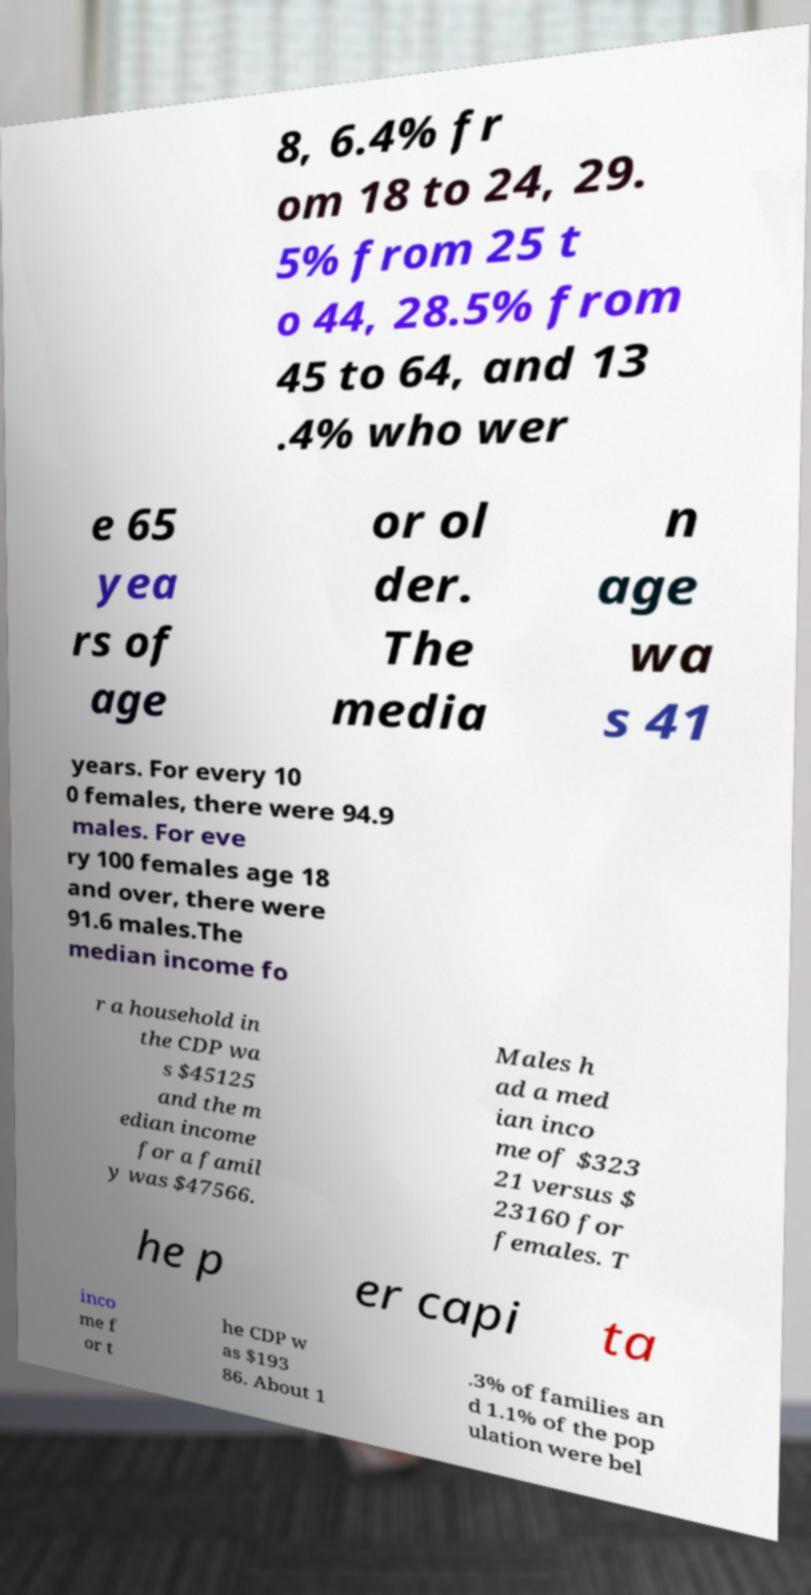Can you read and provide the text displayed in the image?This photo seems to have some interesting text. Can you extract and type it out for me? 8, 6.4% fr om 18 to 24, 29. 5% from 25 t o 44, 28.5% from 45 to 64, and 13 .4% who wer e 65 yea rs of age or ol der. The media n age wa s 41 years. For every 10 0 females, there were 94.9 males. For eve ry 100 females age 18 and over, there were 91.6 males.The median income fo r a household in the CDP wa s $45125 and the m edian income for a famil y was $47566. Males h ad a med ian inco me of $323 21 versus $ 23160 for females. T he p er capi ta inco me f or t he CDP w as $193 86. About 1 .3% of families an d 1.1% of the pop ulation were bel 